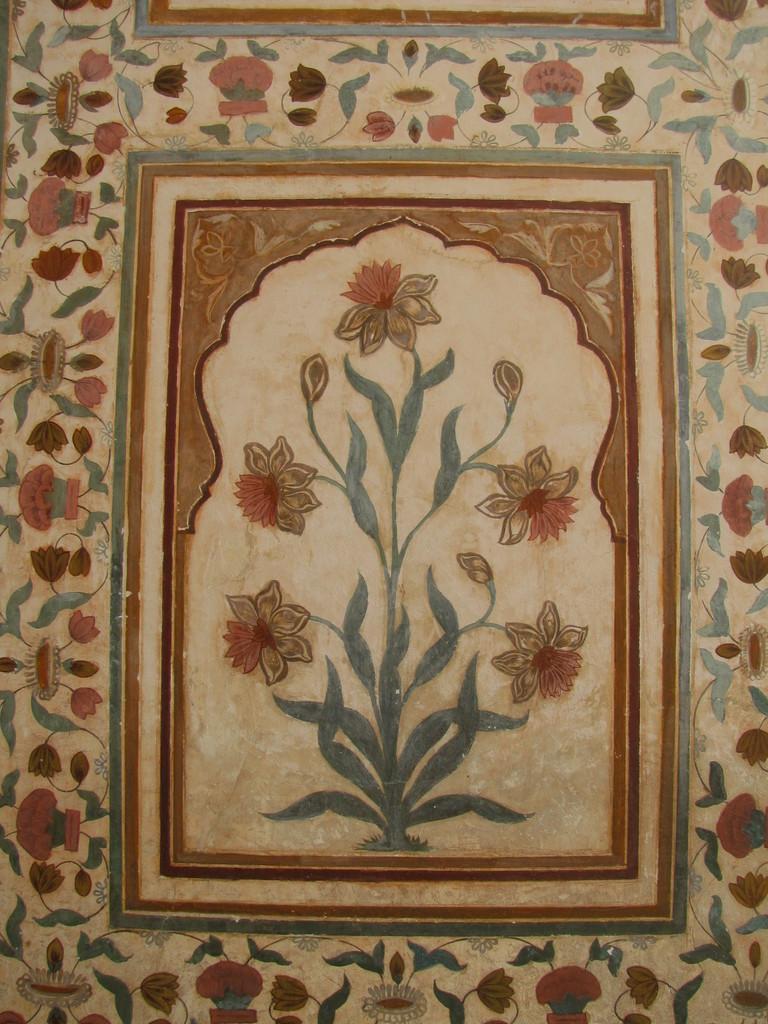Could you give a brief overview of what you see in this image? In this image I can see wall painting details. It has a flower plant. 